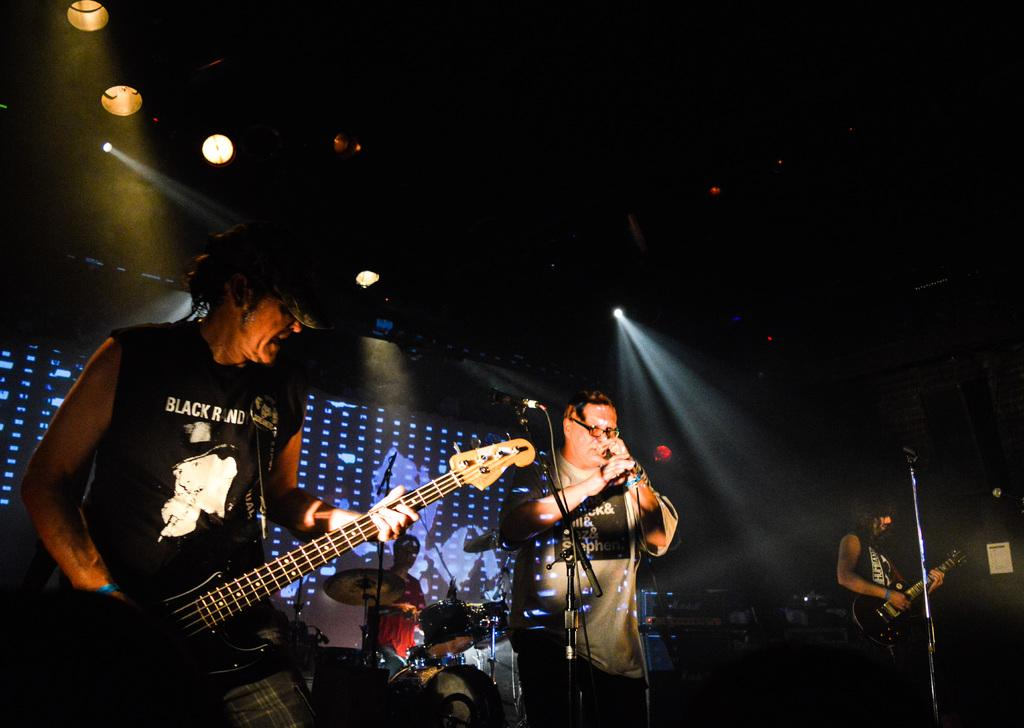How many people are present in the image? There are four people in the image. What objects are visible in the image that are related to music? There are microphones and musical instruments in the image. Which specific musical instruments are being held by two of the people in the image? Two people are holding guitars in the image. What type of lighting is present in the image? There are lights in the image. What is the color of the background in the image? The background of the image is dark. Can you see any smoke coming from the instruments in the image? There is no smoke visible in the image; it only features people, microphones, musical instruments, lights, and a dark background. 